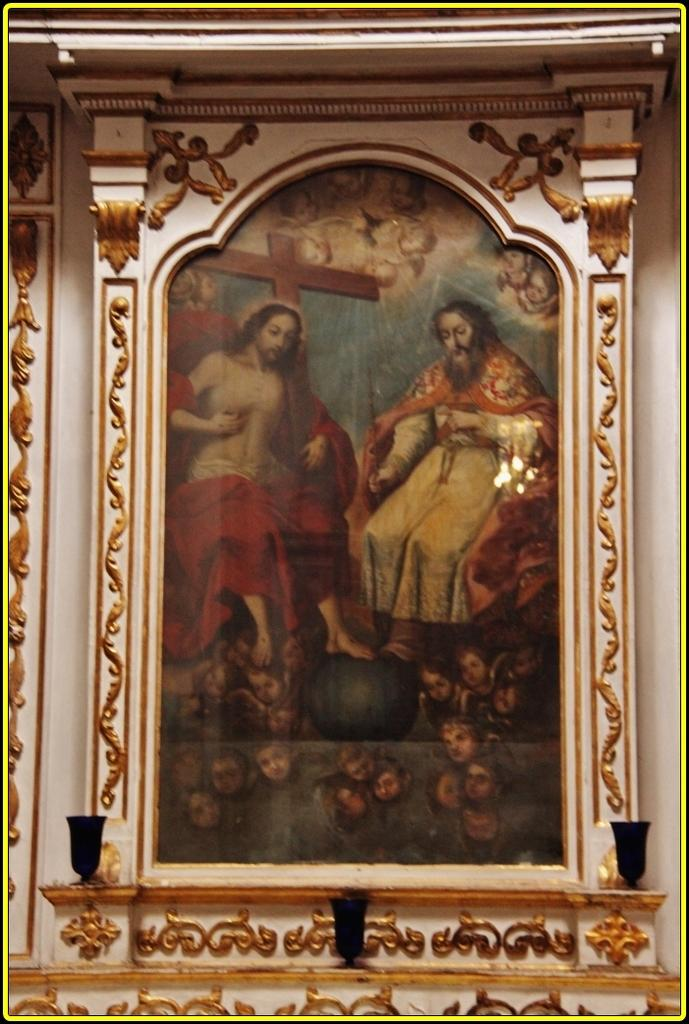What is the main feature in the center of the image? There is a wall in the center of the image. What is attached to the wall? There is a photo frame on the wall. What is depicted inside the photo frame? The photo frame contains a cross. Are there any people in the photo frame? Yes, two persons are sitting in the photo frame. What type of pie is being served by the squirrel in the image? There is no squirrel or pie present in the image. What type of polish is being applied to the cross in the image? There is no polish or activity related to polishing in the image; the cross is simply depicted inside the photo frame. 